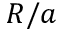<formula> <loc_0><loc_0><loc_500><loc_500>R / a</formula> 